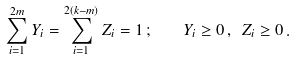Convert formula to latex. <formula><loc_0><loc_0><loc_500><loc_500>\sum _ { i = 1 } ^ { 2 m } Y _ { i } = \sum _ { i = 1 } ^ { 2 ( k - m ) } Z _ { i } = 1 \, ; \quad Y _ { i } \geq 0 \, , \ Z _ { i } \geq 0 \, .</formula> 